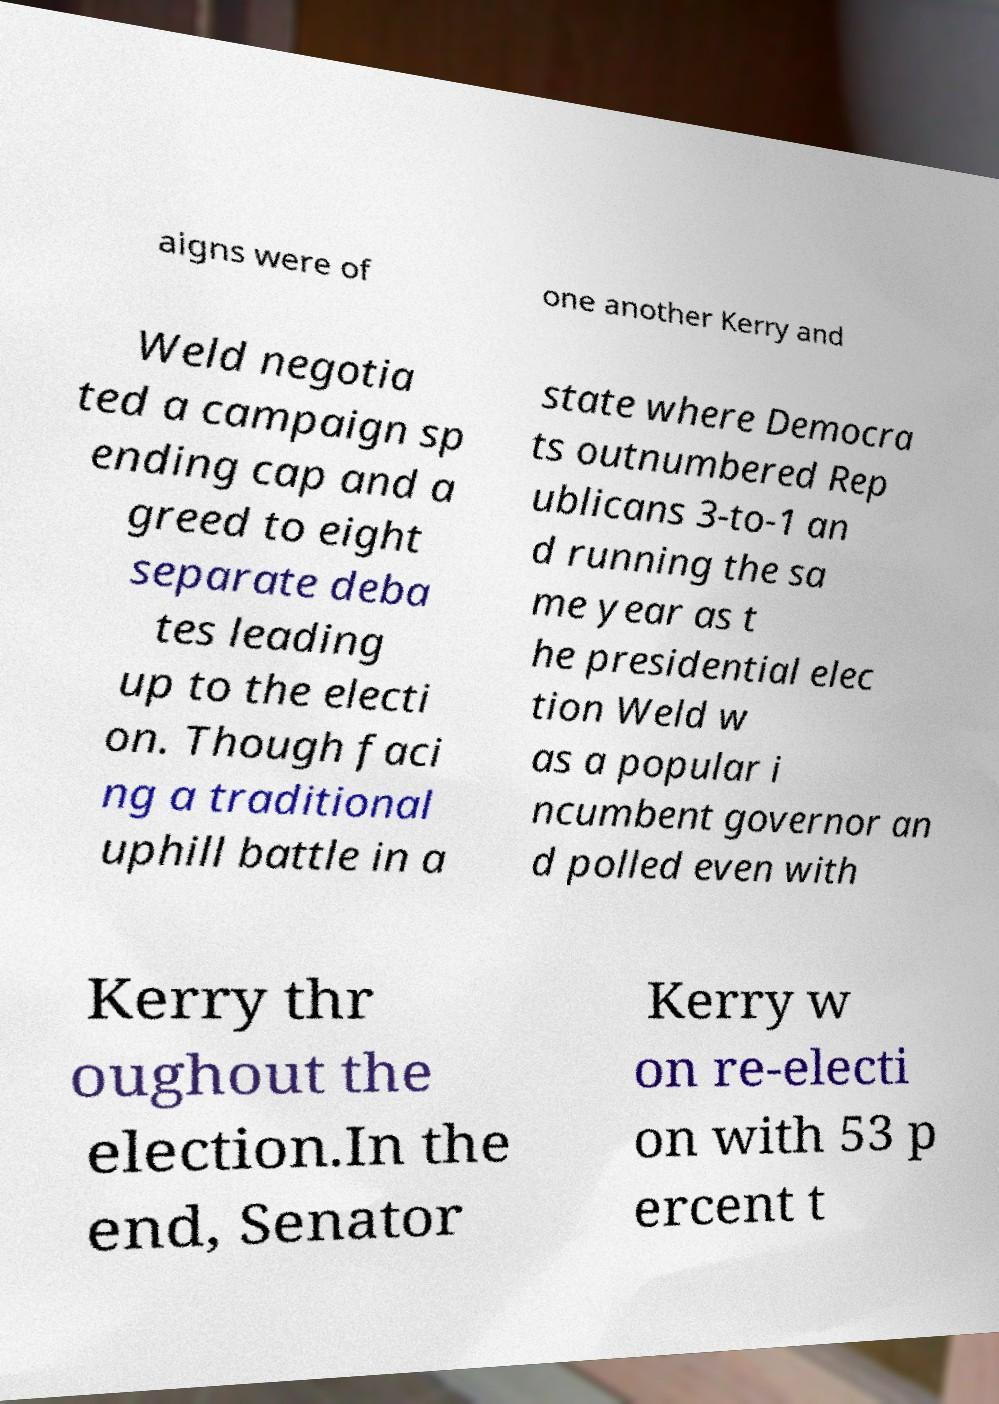For documentation purposes, I need the text within this image transcribed. Could you provide that? aigns were of one another Kerry and Weld negotia ted a campaign sp ending cap and a greed to eight separate deba tes leading up to the electi on. Though faci ng a traditional uphill battle in a state where Democra ts outnumbered Rep ublicans 3-to-1 an d running the sa me year as t he presidential elec tion Weld w as a popular i ncumbent governor an d polled even with Kerry thr oughout the election.In the end, Senator Kerry w on re-electi on with 53 p ercent t 